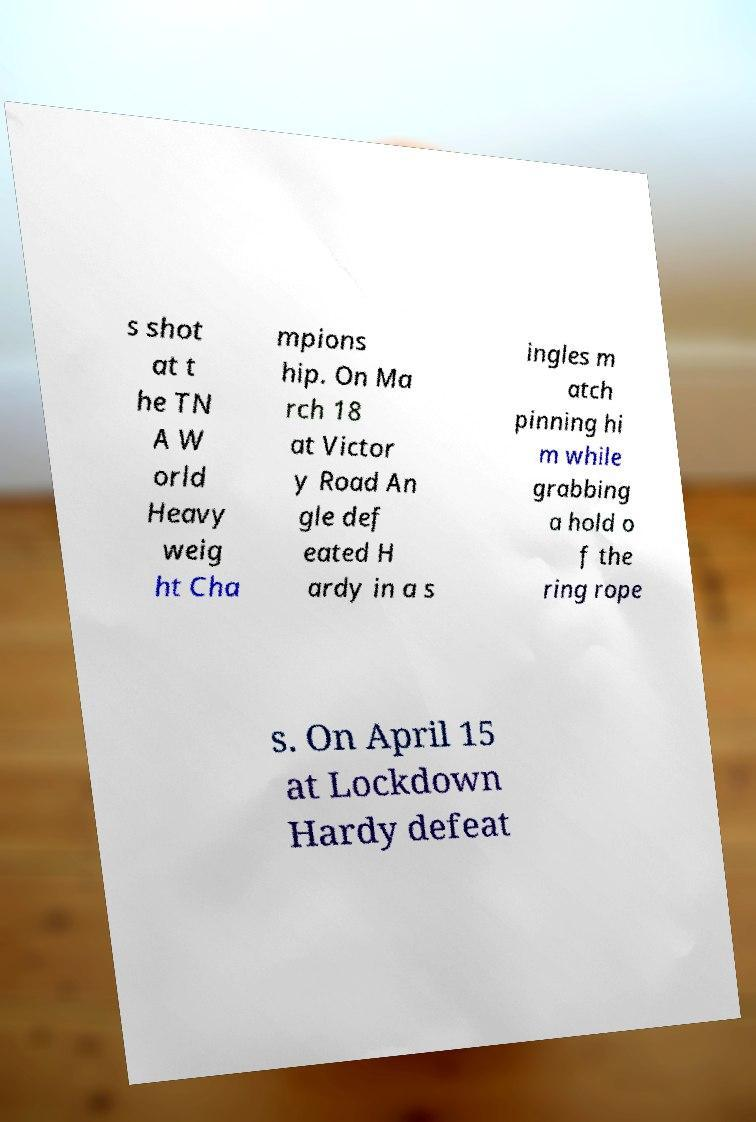What messages or text are displayed in this image? I need them in a readable, typed format. s shot at t he TN A W orld Heavy weig ht Cha mpions hip. On Ma rch 18 at Victor y Road An gle def eated H ardy in a s ingles m atch pinning hi m while grabbing a hold o f the ring rope s. On April 15 at Lockdown Hardy defeat 